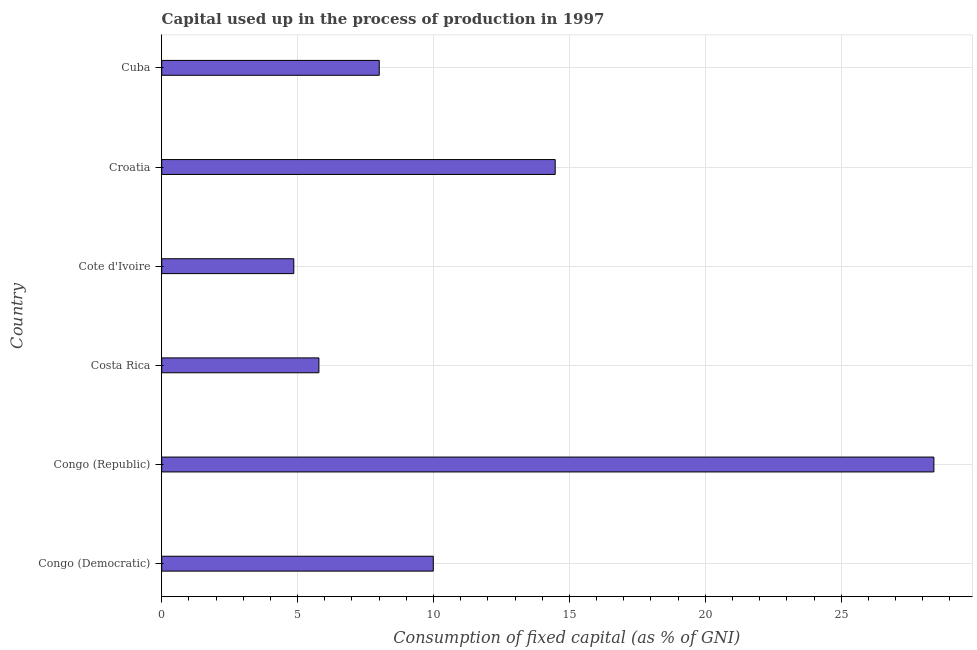Does the graph contain any zero values?
Your answer should be very brief. No. What is the title of the graph?
Give a very brief answer. Capital used up in the process of production in 1997. What is the label or title of the X-axis?
Provide a short and direct response. Consumption of fixed capital (as % of GNI). What is the consumption of fixed capital in Congo (Republic)?
Your response must be concise. 28.41. Across all countries, what is the maximum consumption of fixed capital?
Your answer should be compact. 28.41. Across all countries, what is the minimum consumption of fixed capital?
Make the answer very short. 4.86. In which country was the consumption of fixed capital maximum?
Your answer should be compact. Congo (Republic). In which country was the consumption of fixed capital minimum?
Provide a succinct answer. Cote d'Ivoire. What is the sum of the consumption of fixed capital?
Offer a very short reply. 71.52. What is the difference between the consumption of fixed capital in Congo (Republic) and Cuba?
Provide a succinct answer. 20.41. What is the average consumption of fixed capital per country?
Provide a short and direct response. 11.92. What is the median consumption of fixed capital?
Your response must be concise. 9. What is the ratio of the consumption of fixed capital in Costa Rica to that in Cuba?
Keep it short and to the point. 0.72. Is the consumption of fixed capital in Cote d'Ivoire less than that in Croatia?
Offer a very short reply. Yes. What is the difference between the highest and the second highest consumption of fixed capital?
Give a very brief answer. 13.93. Is the sum of the consumption of fixed capital in Cote d'Ivoire and Cuba greater than the maximum consumption of fixed capital across all countries?
Make the answer very short. No. What is the difference between the highest and the lowest consumption of fixed capital?
Provide a succinct answer. 23.55. In how many countries, is the consumption of fixed capital greater than the average consumption of fixed capital taken over all countries?
Ensure brevity in your answer.  2. How many bars are there?
Your answer should be compact. 6. Are all the bars in the graph horizontal?
Offer a very short reply. Yes. What is the difference between two consecutive major ticks on the X-axis?
Your answer should be compact. 5. Are the values on the major ticks of X-axis written in scientific E-notation?
Ensure brevity in your answer.  No. What is the Consumption of fixed capital (as % of GNI) in Congo (Democratic)?
Offer a terse response. 9.99. What is the Consumption of fixed capital (as % of GNI) in Congo (Republic)?
Offer a terse response. 28.41. What is the Consumption of fixed capital (as % of GNI) in Costa Rica?
Provide a short and direct response. 5.78. What is the Consumption of fixed capital (as % of GNI) in Cote d'Ivoire?
Your response must be concise. 4.86. What is the Consumption of fixed capital (as % of GNI) of Croatia?
Offer a terse response. 14.48. What is the Consumption of fixed capital (as % of GNI) in Cuba?
Give a very brief answer. 8. What is the difference between the Consumption of fixed capital (as % of GNI) in Congo (Democratic) and Congo (Republic)?
Provide a short and direct response. -18.42. What is the difference between the Consumption of fixed capital (as % of GNI) in Congo (Democratic) and Costa Rica?
Provide a short and direct response. 4.21. What is the difference between the Consumption of fixed capital (as % of GNI) in Congo (Democratic) and Cote d'Ivoire?
Your response must be concise. 5.13. What is the difference between the Consumption of fixed capital (as % of GNI) in Congo (Democratic) and Croatia?
Offer a terse response. -4.48. What is the difference between the Consumption of fixed capital (as % of GNI) in Congo (Democratic) and Cuba?
Offer a terse response. 1.99. What is the difference between the Consumption of fixed capital (as % of GNI) in Congo (Republic) and Costa Rica?
Give a very brief answer. 22.62. What is the difference between the Consumption of fixed capital (as % of GNI) in Congo (Republic) and Cote d'Ivoire?
Offer a terse response. 23.55. What is the difference between the Consumption of fixed capital (as % of GNI) in Congo (Republic) and Croatia?
Provide a short and direct response. 13.93. What is the difference between the Consumption of fixed capital (as % of GNI) in Congo (Republic) and Cuba?
Make the answer very short. 20.41. What is the difference between the Consumption of fixed capital (as % of GNI) in Costa Rica and Cote d'Ivoire?
Ensure brevity in your answer.  0.92. What is the difference between the Consumption of fixed capital (as % of GNI) in Costa Rica and Croatia?
Offer a very short reply. -8.69. What is the difference between the Consumption of fixed capital (as % of GNI) in Costa Rica and Cuba?
Your answer should be very brief. -2.22. What is the difference between the Consumption of fixed capital (as % of GNI) in Cote d'Ivoire and Croatia?
Your response must be concise. -9.62. What is the difference between the Consumption of fixed capital (as % of GNI) in Cote d'Ivoire and Cuba?
Offer a very short reply. -3.14. What is the difference between the Consumption of fixed capital (as % of GNI) in Croatia and Cuba?
Make the answer very short. 6.47. What is the ratio of the Consumption of fixed capital (as % of GNI) in Congo (Democratic) to that in Congo (Republic)?
Your response must be concise. 0.35. What is the ratio of the Consumption of fixed capital (as % of GNI) in Congo (Democratic) to that in Costa Rica?
Your answer should be compact. 1.73. What is the ratio of the Consumption of fixed capital (as % of GNI) in Congo (Democratic) to that in Cote d'Ivoire?
Offer a very short reply. 2.06. What is the ratio of the Consumption of fixed capital (as % of GNI) in Congo (Democratic) to that in Croatia?
Your answer should be compact. 0.69. What is the ratio of the Consumption of fixed capital (as % of GNI) in Congo (Democratic) to that in Cuba?
Offer a very short reply. 1.25. What is the ratio of the Consumption of fixed capital (as % of GNI) in Congo (Republic) to that in Costa Rica?
Your response must be concise. 4.91. What is the ratio of the Consumption of fixed capital (as % of GNI) in Congo (Republic) to that in Cote d'Ivoire?
Make the answer very short. 5.85. What is the ratio of the Consumption of fixed capital (as % of GNI) in Congo (Republic) to that in Croatia?
Keep it short and to the point. 1.96. What is the ratio of the Consumption of fixed capital (as % of GNI) in Congo (Republic) to that in Cuba?
Your answer should be very brief. 3.55. What is the ratio of the Consumption of fixed capital (as % of GNI) in Costa Rica to that in Cote d'Ivoire?
Keep it short and to the point. 1.19. What is the ratio of the Consumption of fixed capital (as % of GNI) in Costa Rica to that in Cuba?
Provide a short and direct response. 0.72. What is the ratio of the Consumption of fixed capital (as % of GNI) in Cote d'Ivoire to that in Croatia?
Make the answer very short. 0.34. What is the ratio of the Consumption of fixed capital (as % of GNI) in Cote d'Ivoire to that in Cuba?
Your answer should be compact. 0.61. What is the ratio of the Consumption of fixed capital (as % of GNI) in Croatia to that in Cuba?
Keep it short and to the point. 1.81. 